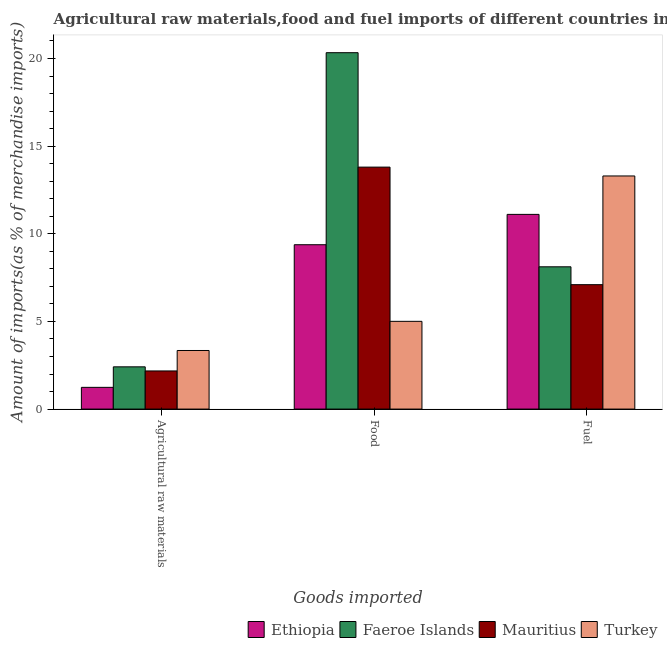How many groups of bars are there?
Provide a short and direct response. 3. Are the number of bars per tick equal to the number of legend labels?
Provide a succinct answer. Yes. Are the number of bars on each tick of the X-axis equal?
Keep it short and to the point. Yes. How many bars are there on the 3rd tick from the right?
Your answer should be compact. 4. What is the label of the 1st group of bars from the left?
Your response must be concise. Agricultural raw materials. What is the percentage of fuel imports in Ethiopia?
Your response must be concise. 11.11. Across all countries, what is the maximum percentage of fuel imports?
Give a very brief answer. 13.3. Across all countries, what is the minimum percentage of food imports?
Your answer should be very brief. 5.01. In which country was the percentage of food imports maximum?
Your response must be concise. Faeroe Islands. In which country was the percentage of raw materials imports minimum?
Provide a short and direct response. Ethiopia. What is the total percentage of fuel imports in the graph?
Provide a short and direct response. 39.62. What is the difference between the percentage of raw materials imports in Mauritius and that in Faeroe Islands?
Your answer should be very brief. -0.23. What is the difference between the percentage of raw materials imports in Faeroe Islands and the percentage of food imports in Mauritius?
Offer a very short reply. -11.39. What is the average percentage of food imports per country?
Offer a very short reply. 12.13. What is the difference between the percentage of fuel imports and percentage of food imports in Faeroe Islands?
Make the answer very short. -12.22. In how many countries, is the percentage of food imports greater than 20 %?
Ensure brevity in your answer.  1. What is the ratio of the percentage of food imports in Turkey to that in Ethiopia?
Give a very brief answer. 0.53. Is the percentage of food imports in Faeroe Islands less than that in Mauritius?
Make the answer very short. No. Is the difference between the percentage of food imports in Mauritius and Ethiopia greater than the difference between the percentage of fuel imports in Mauritius and Ethiopia?
Your response must be concise. Yes. What is the difference between the highest and the second highest percentage of food imports?
Keep it short and to the point. 6.53. What is the difference between the highest and the lowest percentage of fuel imports?
Your answer should be very brief. 6.2. What does the 1st bar from the left in Food represents?
Your answer should be very brief. Ethiopia. What does the 3rd bar from the right in Fuel represents?
Make the answer very short. Faeroe Islands. Does the graph contain any zero values?
Make the answer very short. No. How many legend labels are there?
Provide a succinct answer. 4. How are the legend labels stacked?
Offer a terse response. Horizontal. What is the title of the graph?
Ensure brevity in your answer.  Agricultural raw materials,food and fuel imports of different countries in 1999. Does "Uruguay" appear as one of the legend labels in the graph?
Your response must be concise. No. What is the label or title of the X-axis?
Provide a succinct answer. Goods imported. What is the label or title of the Y-axis?
Provide a short and direct response. Amount of imports(as % of merchandise imports). What is the Amount of imports(as % of merchandise imports) of Ethiopia in Agricultural raw materials?
Ensure brevity in your answer.  1.24. What is the Amount of imports(as % of merchandise imports) of Faeroe Islands in Agricultural raw materials?
Keep it short and to the point. 2.41. What is the Amount of imports(as % of merchandise imports) of Mauritius in Agricultural raw materials?
Offer a very short reply. 2.18. What is the Amount of imports(as % of merchandise imports) of Turkey in Agricultural raw materials?
Offer a very short reply. 3.34. What is the Amount of imports(as % of merchandise imports) of Ethiopia in Food?
Offer a very short reply. 9.38. What is the Amount of imports(as % of merchandise imports) in Faeroe Islands in Food?
Provide a short and direct response. 20.33. What is the Amount of imports(as % of merchandise imports) in Mauritius in Food?
Offer a terse response. 13.8. What is the Amount of imports(as % of merchandise imports) of Turkey in Food?
Provide a succinct answer. 5.01. What is the Amount of imports(as % of merchandise imports) in Ethiopia in Fuel?
Provide a short and direct response. 11.11. What is the Amount of imports(as % of merchandise imports) in Faeroe Islands in Fuel?
Provide a succinct answer. 8.12. What is the Amount of imports(as % of merchandise imports) of Mauritius in Fuel?
Your response must be concise. 7.1. What is the Amount of imports(as % of merchandise imports) in Turkey in Fuel?
Provide a succinct answer. 13.3. Across all Goods imported, what is the maximum Amount of imports(as % of merchandise imports) of Ethiopia?
Offer a terse response. 11.11. Across all Goods imported, what is the maximum Amount of imports(as % of merchandise imports) of Faeroe Islands?
Your answer should be very brief. 20.33. Across all Goods imported, what is the maximum Amount of imports(as % of merchandise imports) of Mauritius?
Your answer should be compact. 13.8. Across all Goods imported, what is the maximum Amount of imports(as % of merchandise imports) in Turkey?
Your answer should be compact. 13.3. Across all Goods imported, what is the minimum Amount of imports(as % of merchandise imports) in Ethiopia?
Ensure brevity in your answer.  1.24. Across all Goods imported, what is the minimum Amount of imports(as % of merchandise imports) in Faeroe Islands?
Offer a terse response. 2.41. Across all Goods imported, what is the minimum Amount of imports(as % of merchandise imports) of Mauritius?
Provide a short and direct response. 2.18. Across all Goods imported, what is the minimum Amount of imports(as % of merchandise imports) of Turkey?
Offer a very short reply. 3.34. What is the total Amount of imports(as % of merchandise imports) in Ethiopia in the graph?
Make the answer very short. 21.72. What is the total Amount of imports(as % of merchandise imports) of Faeroe Islands in the graph?
Ensure brevity in your answer.  30.86. What is the total Amount of imports(as % of merchandise imports) in Mauritius in the graph?
Your response must be concise. 23.08. What is the total Amount of imports(as % of merchandise imports) in Turkey in the graph?
Give a very brief answer. 21.65. What is the difference between the Amount of imports(as % of merchandise imports) in Ethiopia in Agricultural raw materials and that in Food?
Give a very brief answer. -8.14. What is the difference between the Amount of imports(as % of merchandise imports) of Faeroe Islands in Agricultural raw materials and that in Food?
Keep it short and to the point. -17.92. What is the difference between the Amount of imports(as % of merchandise imports) in Mauritius in Agricultural raw materials and that in Food?
Provide a short and direct response. -11.63. What is the difference between the Amount of imports(as % of merchandise imports) in Turkey in Agricultural raw materials and that in Food?
Provide a succinct answer. -1.66. What is the difference between the Amount of imports(as % of merchandise imports) of Ethiopia in Agricultural raw materials and that in Fuel?
Ensure brevity in your answer.  -9.87. What is the difference between the Amount of imports(as % of merchandise imports) of Faeroe Islands in Agricultural raw materials and that in Fuel?
Make the answer very short. -5.71. What is the difference between the Amount of imports(as % of merchandise imports) of Mauritius in Agricultural raw materials and that in Fuel?
Offer a terse response. -4.92. What is the difference between the Amount of imports(as % of merchandise imports) of Turkey in Agricultural raw materials and that in Fuel?
Your answer should be very brief. -9.96. What is the difference between the Amount of imports(as % of merchandise imports) of Ethiopia in Food and that in Fuel?
Give a very brief answer. -1.73. What is the difference between the Amount of imports(as % of merchandise imports) in Faeroe Islands in Food and that in Fuel?
Keep it short and to the point. 12.22. What is the difference between the Amount of imports(as % of merchandise imports) in Mauritius in Food and that in Fuel?
Provide a succinct answer. 6.71. What is the difference between the Amount of imports(as % of merchandise imports) of Turkey in Food and that in Fuel?
Your answer should be compact. -8.29. What is the difference between the Amount of imports(as % of merchandise imports) of Ethiopia in Agricultural raw materials and the Amount of imports(as % of merchandise imports) of Faeroe Islands in Food?
Make the answer very short. -19.09. What is the difference between the Amount of imports(as % of merchandise imports) of Ethiopia in Agricultural raw materials and the Amount of imports(as % of merchandise imports) of Mauritius in Food?
Give a very brief answer. -12.56. What is the difference between the Amount of imports(as % of merchandise imports) of Ethiopia in Agricultural raw materials and the Amount of imports(as % of merchandise imports) of Turkey in Food?
Provide a short and direct response. -3.77. What is the difference between the Amount of imports(as % of merchandise imports) in Faeroe Islands in Agricultural raw materials and the Amount of imports(as % of merchandise imports) in Mauritius in Food?
Your answer should be very brief. -11.39. What is the difference between the Amount of imports(as % of merchandise imports) in Faeroe Islands in Agricultural raw materials and the Amount of imports(as % of merchandise imports) in Turkey in Food?
Offer a terse response. -2.6. What is the difference between the Amount of imports(as % of merchandise imports) of Mauritius in Agricultural raw materials and the Amount of imports(as % of merchandise imports) of Turkey in Food?
Your response must be concise. -2.83. What is the difference between the Amount of imports(as % of merchandise imports) of Ethiopia in Agricultural raw materials and the Amount of imports(as % of merchandise imports) of Faeroe Islands in Fuel?
Make the answer very short. -6.88. What is the difference between the Amount of imports(as % of merchandise imports) in Ethiopia in Agricultural raw materials and the Amount of imports(as % of merchandise imports) in Mauritius in Fuel?
Offer a very short reply. -5.86. What is the difference between the Amount of imports(as % of merchandise imports) of Ethiopia in Agricultural raw materials and the Amount of imports(as % of merchandise imports) of Turkey in Fuel?
Your response must be concise. -12.06. What is the difference between the Amount of imports(as % of merchandise imports) of Faeroe Islands in Agricultural raw materials and the Amount of imports(as % of merchandise imports) of Mauritius in Fuel?
Provide a short and direct response. -4.69. What is the difference between the Amount of imports(as % of merchandise imports) of Faeroe Islands in Agricultural raw materials and the Amount of imports(as % of merchandise imports) of Turkey in Fuel?
Give a very brief answer. -10.89. What is the difference between the Amount of imports(as % of merchandise imports) in Mauritius in Agricultural raw materials and the Amount of imports(as % of merchandise imports) in Turkey in Fuel?
Give a very brief answer. -11.12. What is the difference between the Amount of imports(as % of merchandise imports) of Ethiopia in Food and the Amount of imports(as % of merchandise imports) of Faeroe Islands in Fuel?
Your answer should be compact. 1.26. What is the difference between the Amount of imports(as % of merchandise imports) in Ethiopia in Food and the Amount of imports(as % of merchandise imports) in Mauritius in Fuel?
Offer a very short reply. 2.28. What is the difference between the Amount of imports(as % of merchandise imports) of Ethiopia in Food and the Amount of imports(as % of merchandise imports) of Turkey in Fuel?
Provide a short and direct response. -3.92. What is the difference between the Amount of imports(as % of merchandise imports) in Faeroe Islands in Food and the Amount of imports(as % of merchandise imports) in Mauritius in Fuel?
Provide a succinct answer. 13.23. What is the difference between the Amount of imports(as % of merchandise imports) of Faeroe Islands in Food and the Amount of imports(as % of merchandise imports) of Turkey in Fuel?
Provide a succinct answer. 7.03. What is the difference between the Amount of imports(as % of merchandise imports) of Mauritius in Food and the Amount of imports(as % of merchandise imports) of Turkey in Fuel?
Provide a succinct answer. 0.5. What is the average Amount of imports(as % of merchandise imports) in Ethiopia per Goods imported?
Provide a short and direct response. 7.24. What is the average Amount of imports(as % of merchandise imports) in Faeroe Islands per Goods imported?
Your answer should be very brief. 10.29. What is the average Amount of imports(as % of merchandise imports) in Mauritius per Goods imported?
Your answer should be compact. 7.69. What is the average Amount of imports(as % of merchandise imports) of Turkey per Goods imported?
Keep it short and to the point. 7.22. What is the difference between the Amount of imports(as % of merchandise imports) in Ethiopia and Amount of imports(as % of merchandise imports) in Faeroe Islands in Agricultural raw materials?
Provide a succinct answer. -1.17. What is the difference between the Amount of imports(as % of merchandise imports) in Ethiopia and Amount of imports(as % of merchandise imports) in Mauritius in Agricultural raw materials?
Offer a very short reply. -0.94. What is the difference between the Amount of imports(as % of merchandise imports) in Ethiopia and Amount of imports(as % of merchandise imports) in Turkey in Agricultural raw materials?
Keep it short and to the point. -2.1. What is the difference between the Amount of imports(as % of merchandise imports) of Faeroe Islands and Amount of imports(as % of merchandise imports) of Mauritius in Agricultural raw materials?
Make the answer very short. 0.23. What is the difference between the Amount of imports(as % of merchandise imports) in Faeroe Islands and Amount of imports(as % of merchandise imports) in Turkey in Agricultural raw materials?
Offer a very short reply. -0.93. What is the difference between the Amount of imports(as % of merchandise imports) of Mauritius and Amount of imports(as % of merchandise imports) of Turkey in Agricultural raw materials?
Ensure brevity in your answer.  -1.17. What is the difference between the Amount of imports(as % of merchandise imports) in Ethiopia and Amount of imports(as % of merchandise imports) in Faeroe Islands in Food?
Provide a short and direct response. -10.96. What is the difference between the Amount of imports(as % of merchandise imports) of Ethiopia and Amount of imports(as % of merchandise imports) of Mauritius in Food?
Keep it short and to the point. -4.43. What is the difference between the Amount of imports(as % of merchandise imports) in Ethiopia and Amount of imports(as % of merchandise imports) in Turkey in Food?
Keep it short and to the point. 4.37. What is the difference between the Amount of imports(as % of merchandise imports) in Faeroe Islands and Amount of imports(as % of merchandise imports) in Mauritius in Food?
Offer a very short reply. 6.53. What is the difference between the Amount of imports(as % of merchandise imports) in Faeroe Islands and Amount of imports(as % of merchandise imports) in Turkey in Food?
Your answer should be compact. 15.33. What is the difference between the Amount of imports(as % of merchandise imports) in Mauritius and Amount of imports(as % of merchandise imports) in Turkey in Food?
Your response must be concise. 8.8. What is the difference between the Amount of imports(as % of merchandise imports) of Ethiopia and Amount of imports(as % of merchandise imports) of Faeroe Islands in Fuel?
Offer a very short reply. 2.99. What is the difference between the Amount of imports(as % of merchandise imports) in Ethiopia and Amount of imports(as % of merchandise imports) in Mauritius in Fuel?
Your response must be concise. 4.01. What is the difference between the Amount of imports(as % of merchandise imports) in Ethiopia and Amount of imports(as % of merchandise imports) in Turkey in Fuel?
Offer a very short reply. -2.19. What is the difference between the Amount of imports(as % of merchandise imports) in Faeroe Islands and Amount of imports(as % of merchandise imports) in Mauritius in Fuel?
Your answer should be very brief. 1.02. What is the difference between the Amount of imports(as % of merchandise imports) in Faeroe Islands and Amount of imports(as % of merchandise imports) in Turkey in Fuel?
Your answer should be very brief. -5.18. What is the difference between the Amount of imports(as % of merchandise imports) of Mauritius and Amount of imports(as % of merchandise imports) of Turkey in Fuel?
Give a very brief answer. -6.2. What is the ratio of the Amount of imports(as % of merchandise imports) of Ethiopia in Agricultural raw materials to that in Food?
Give a very brief answer. 0.13. What is the ratio of the Amount of imports(as % of merchandise imports) in Faeroe Islands in Agricultural raw materials to that in Food?
Ensure brevity in your answer.  0.12. What is the ratio of the Amount of imports(as % of merchandise imports) of Mauritius in Agricultural raw materials to that in Food?
Provide a succinct answer. 0.16. What is the ratio of the Amount of imports(as % of merchandise imports) of Turkey in Agricultural raw materials to that in Food?
Provide a succinct answer. 0.67. What is the ratio of the Amount of imports(as % of merchandise imports) in Ethiopia in Agricultural raw materials to that in Fuel?
Your response must be concise. 0.11. What is the ratio of the Amount of imports(as % of merchandise imports) in Faeroe Islands in Agricultural raw materials to that in Fuel?
Your answer should be compact. 0.3. What is the ratio of the Amount of imports(as % of merchandise imports) in Mauritius in Agricultural raw materials to that in Fuel?
Give a very brief answer. 0.31. What is the ratio of the Amount of imports(as % of merchandise imports) of Turkey in Agricultural raw materials to that in Fuel?
Keep it short and to the point. 0.25. What is the ratio of the Amount of imports(as % of merchandise imports) of Ethiopia in Food to that in Fuel?
Keep it short and to the point. 0.84. What is the ratio of the Amount of imports(as % of merchandise imports) in Faeroe Islands in Food to that in Fuel?
Offer a terse response. 2.5. What is the ratio of the Amount of imports(as % of merchandise imports) of Mauritius in Food to that in Fuel?
Keep it short and to the point. 1.94. What is the ratio of the Amount of imports(as % of merchandise imports) in Turkey in Food to that in Fuel?
Your answer should be compact. 0.38. What is the difference between the highest and the second highest Amount of imports(as % of merchandise imports) in Ethiopia?
Provide a succinct answer. 1.73. What is the difference between the highest and the second highest Amount of imports(as % of merchandise imports) of Faeroe Islands?
Ensure brevity in your answer.  12.22. What is the difference between the highest and the second highest Amount of imports(as % of merchandise imports) of Mauritius?
Offer a very short reply. 6.71. What is the difference between the highest and the second highest Amount of imports(as % of merchandise imports) in Turkey?
Your answer should be compact. 8.29. What is the difference between the highest and the lowest Amount of imports(as % of merchandise imports) in Ethiopia?
Your answer should be compact. 9.87. What is the difference between the highest and the lowest Amount of imports(as % of merchandise imports) in Faeroe Islands?
Provide a short and direct response. 17.92. What is the difference between the highest and the lowest Amount of imports(as % of merchandise imports) of Mauritius?
Make the answer very short. 11.63. What is the difference between the highest and the lowest Amount of imports(as % of merchandise imports) of Turkey?
Give a very brief answer. 9.96. 